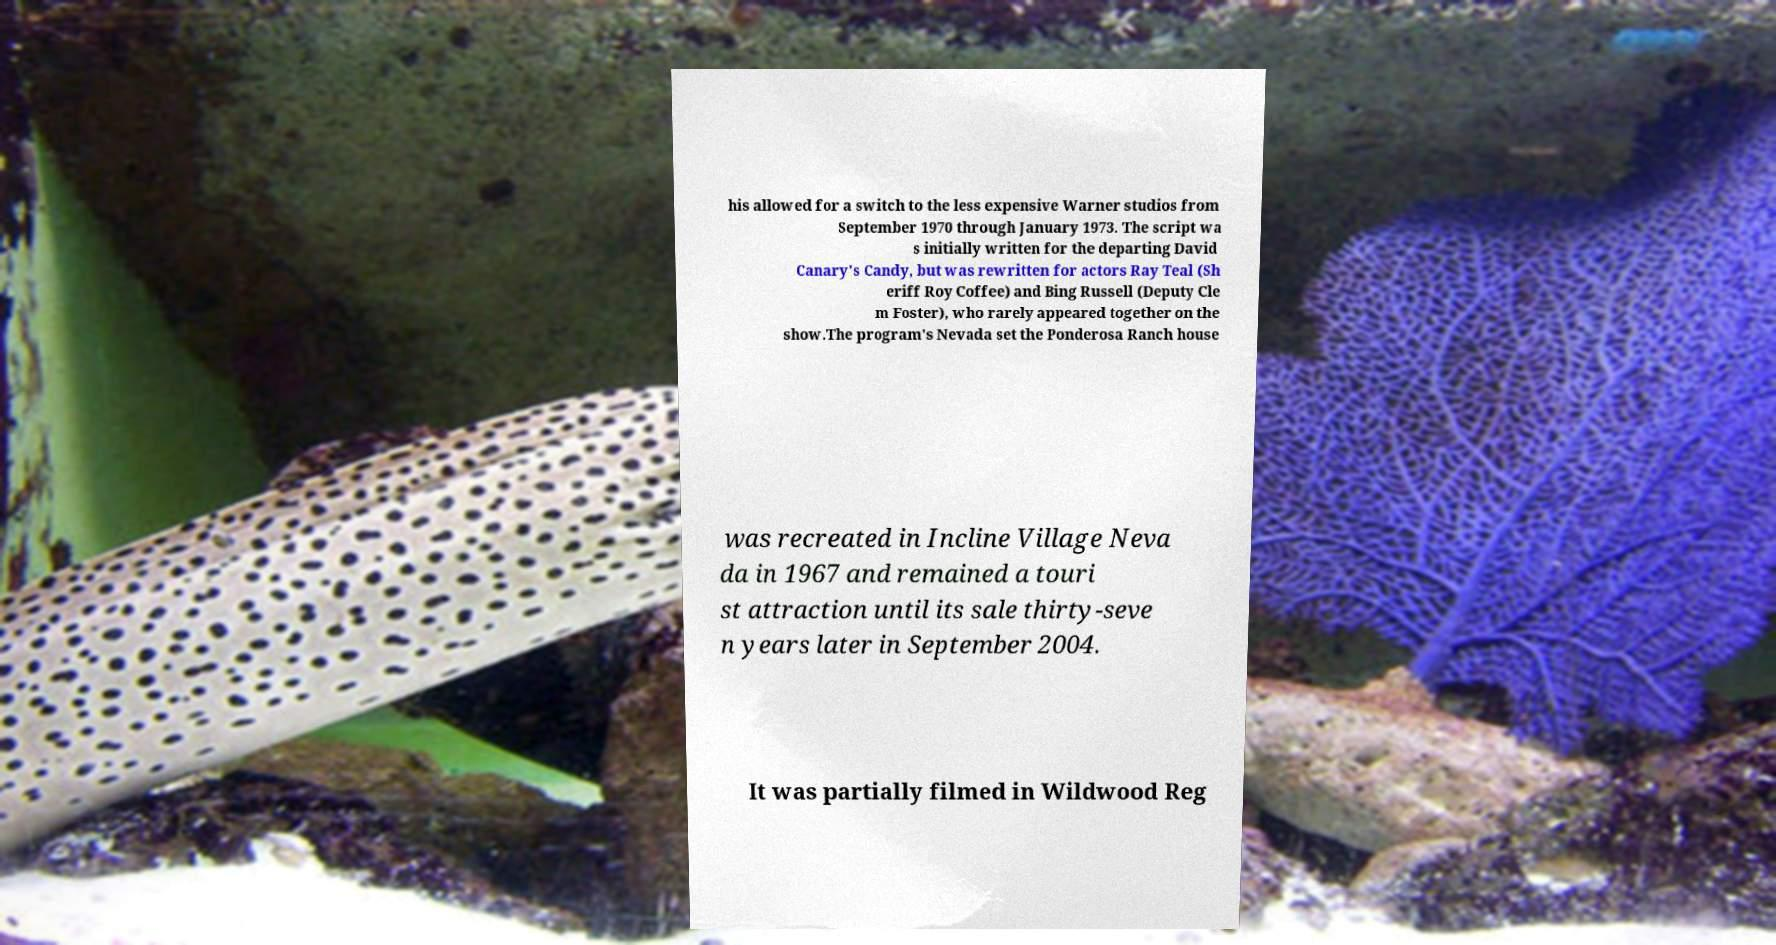Can you accurately transcribe the text from the provided image for me? his allowed for a switch to the less expensive Warner studios from September 1970 through January 1973. The script wa s initially written for the departing David Canary's Candy, but was rewritten for actors Ray Teal (Sh eriff Roy Coffee) and Bing Russell (Deputy Cle m Foster), who rarely appeared together on the show.The program's Nevada set the Ponderosa Ranch house was recreated in Incline Village Neva da in 1967 and remained a touri st attraction until its sale thirty-seve n years later in September 2004. It was partially filmed in Wildwood Reg 